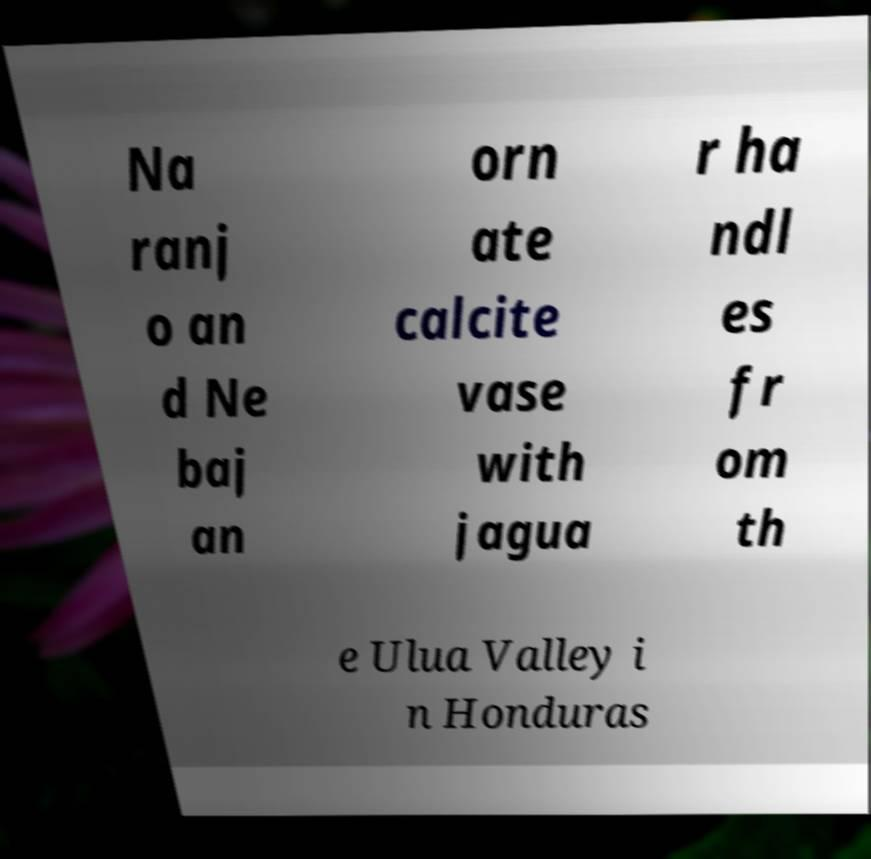Please read and relay the text visible in this image. What does it say? Na ranj o an d Ne baj an orn ate calcite vase with jagua r ha ndl es fr om th e Ulua Valley i n Honduras 